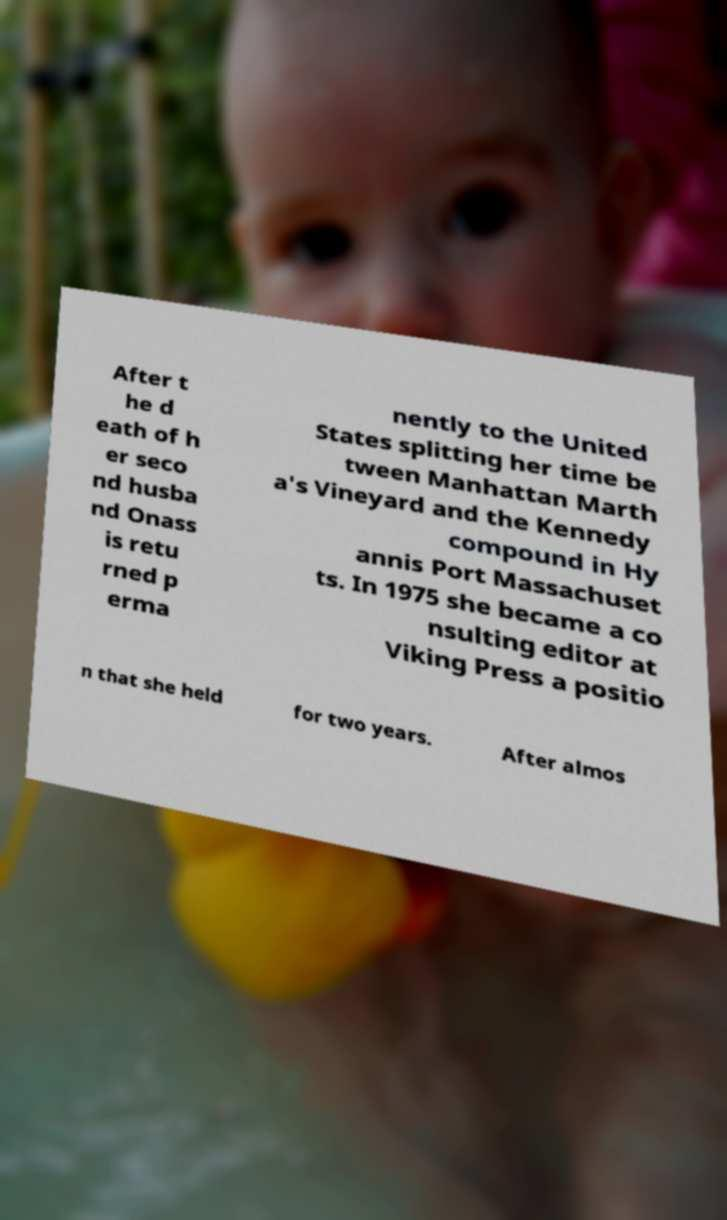There's text embedded in this image that I need extracted. Can you transcribe it verbatim? After t he d eath of h er seco nd husba nd Onass is retu rned p erma nently to the United States splitting her time be tween Manhattan Marth a's Vineyard and the Kennedy compound in Hy annis Port Massachuset ts. In 1975 she became a co nsulting editor at Viking Press a positio n that she held for two years. After almos 